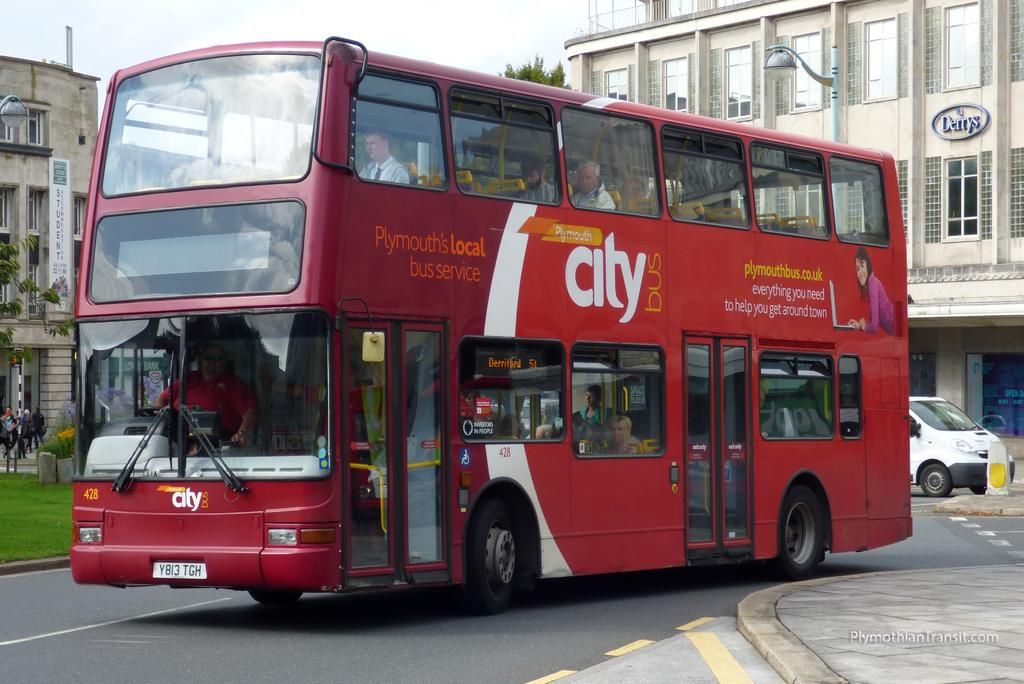<image>
Give a short and clear explanation of the subsequent image. A red double decker City bus from Plymouth's local bus service. 